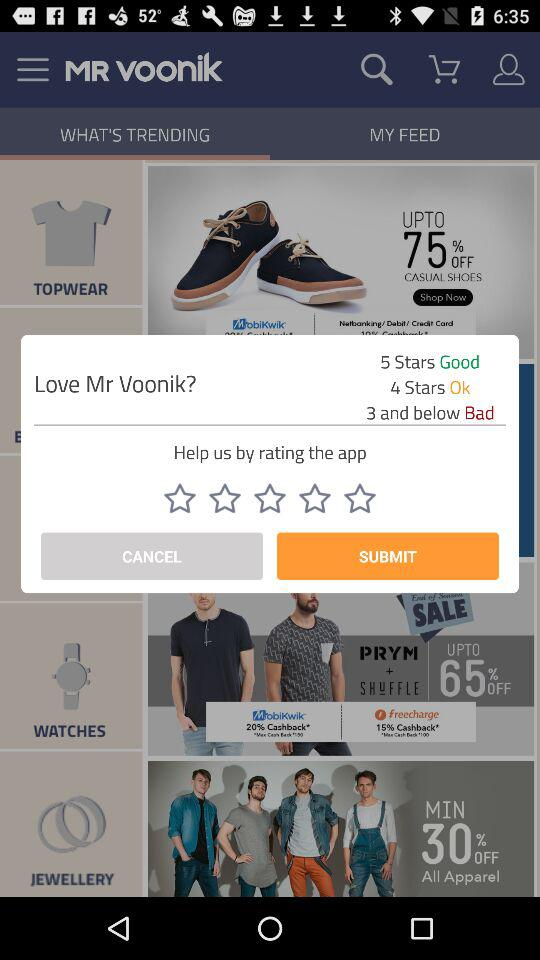What is the application name? The application name is "Mr Voonik". 